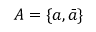<formula> <loc_0><loc_0><loc_500><loc_500>A = \{ a , \bar { a } \}</formula> 